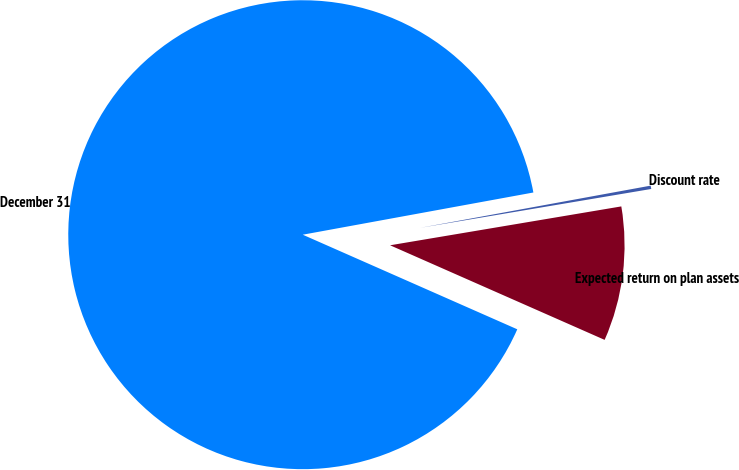Convert chart. <chart><loc_0><loc_0><loc_500><loc_500><pie_chart><fcel>December 31<fcel>Discount rate<fcel>Expected return on plan assets<nl><fcel>90.51%<fcel>0.23%<fcel>9.26%<nl></chart> 